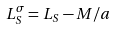<formula> <loc_0><loc_0><loc_500><loc_500>L _ { S } ^ { \sigma } = L _ { S } - M / a</formula> 